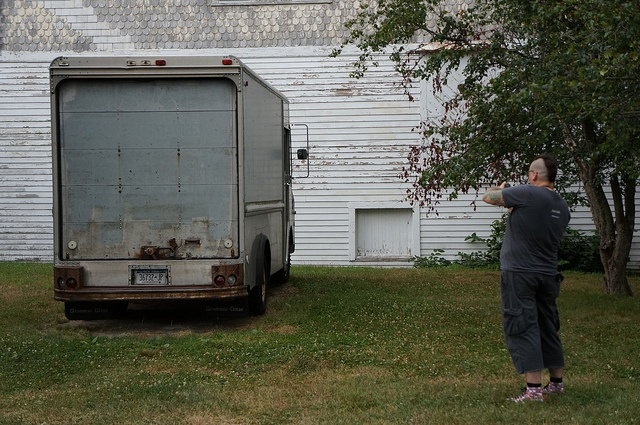Describe the objects in this image and their specific colors. I can see truck in gray, black, darkgray, and lightgray tones and people in gray, black, and darkgreen tones in this image. 